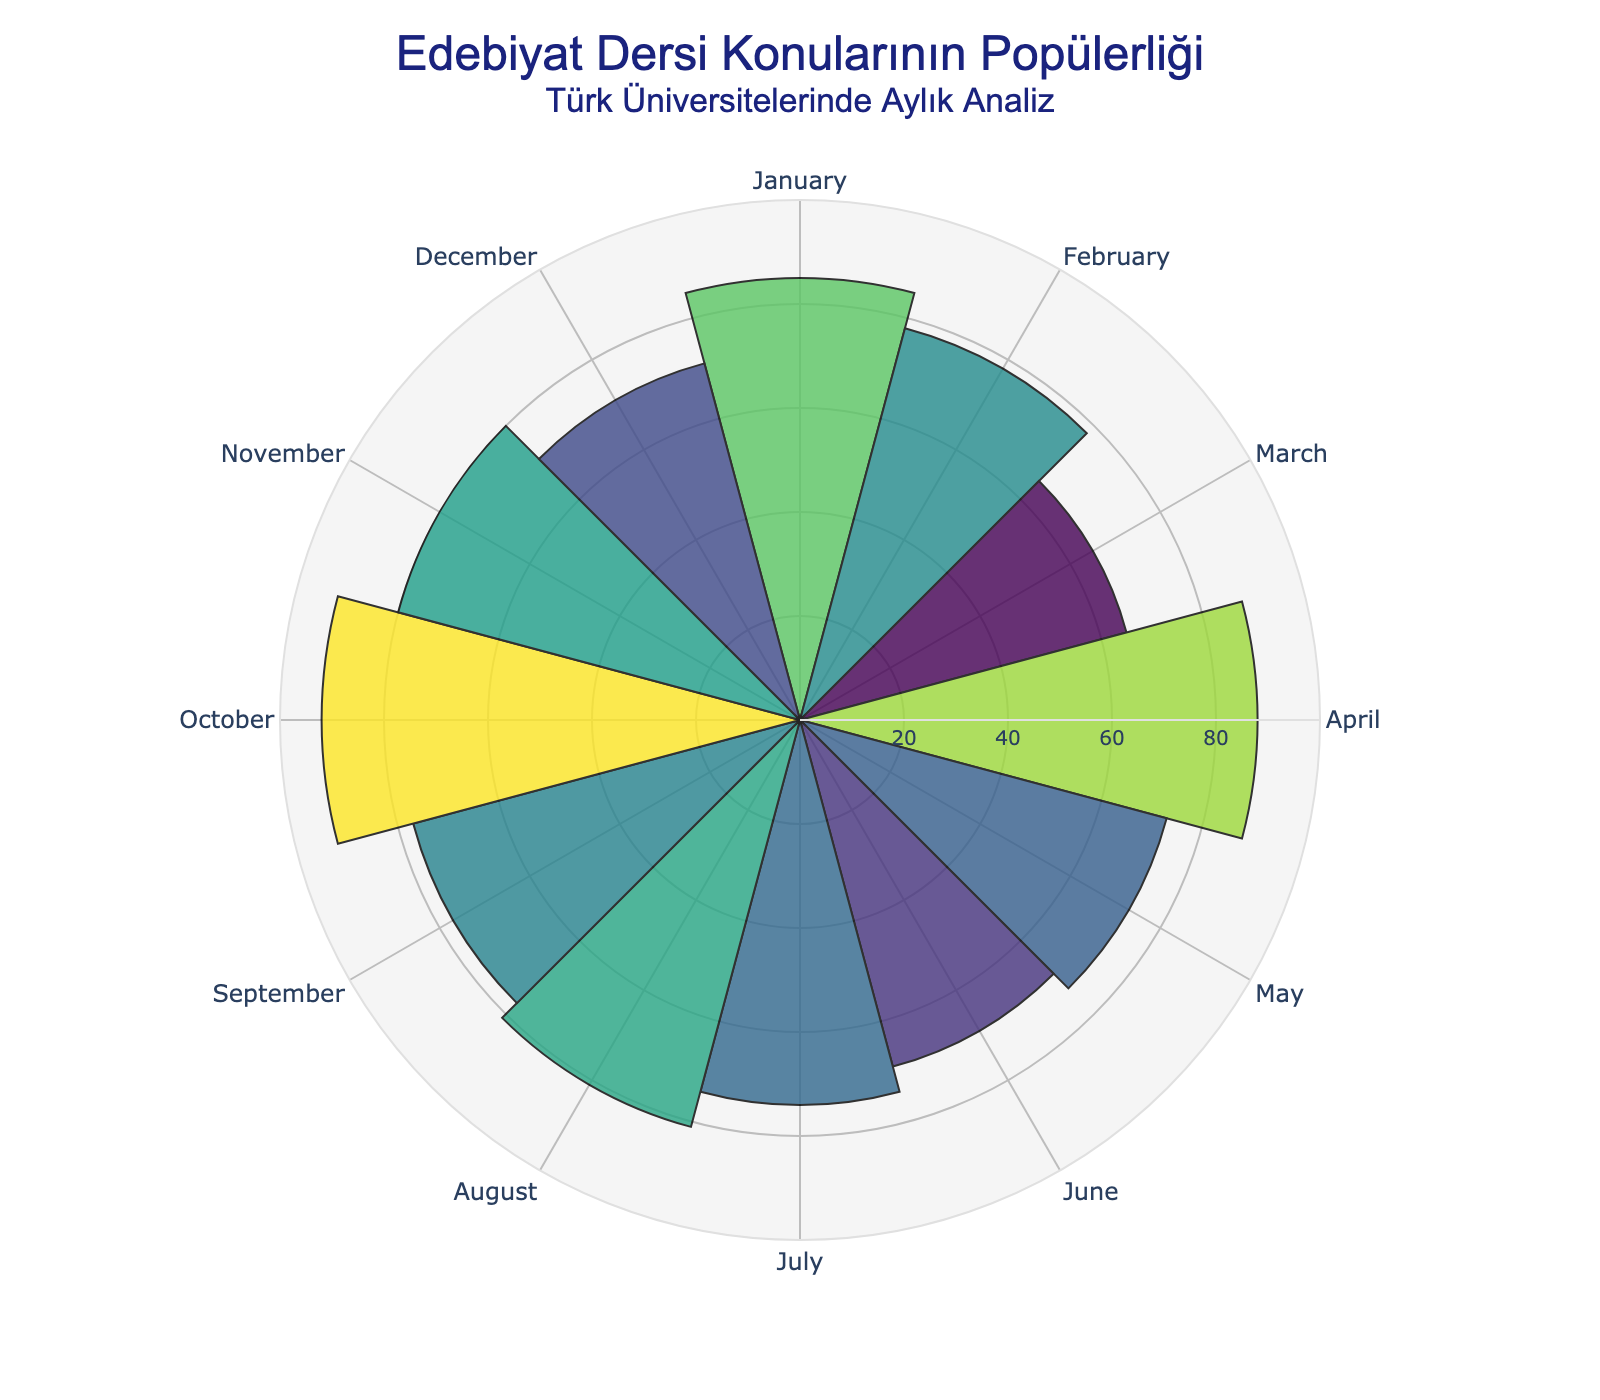What's the title of the figure? The title of the figure is generally located at the top and is usually in a larger font size for emphasis. Here, the title reads "Edebiyat Dersi Konularının Popülerliği" with a subtitle "Türk Üniversitelerinde Aylık Analiz."
Answer: Edebiyat Dersi Konularının Popülerliği Which lecture topic is most popular in October? To find this, locate October on the angular axis and refer to the corresponding bar. The hover text or height of the segment will indicate the most popular topic.
Answer: The Works of Elif Shafak Which month has the least popular lecture topic? By looking at the polar segments, we identify the smallest bar, which corresponds to March. The height of the polar bar or hover text gives us the topic and popularity.
Answer: March What's the average popularity of all lecture topics? Sum all the popularity values and divide by the number of lecture topics. The values are 85, 78, 65, 88, 73, 69, 74, 81, 77, 92, 80, 71. The average is (85+78+65+88+73+69+74+81+77+92+80+71)/12.
Answer: 77.25 Which two months have the closest lecture topic popularity values? Compare the popularity values visually or hover over each segment to find the two with the closest values. February (78) and September (77) have a difference of 1.
Answer: February and September What is the combined popularity of lecture topics in January and December? Add the popularity values for January (85) and December (71). The computation is 85 + 71.
Answer: 156 Are lecture topics more popular in the first half or the second half of the year? Sum the popularity values from January to June, and from July to December, then compare the two sums. First half: 85+78+65+88+73+69 = 458; Second half: 74+81+77+92+80+71 = 475.
Answer: Second half Which lecture topic discussed in August has a corresponding popularity value? Find August on the angular axis or the polar bar corresponding to it, and refer to the hover text which mentions the topic and its popularity.
Answer: Literary Translation: Challenges and Triumphs What is the range of lecture topic popularity values? Subtract the smallest popularity value from the largest. The smallest is 65 (March), and the largest is 92 (October). The range is 92 - 65.
Answer: 27 Which lecture topic had a noticeable peak in popularity compared to its neighboring months? Identify the spikes in the figure by comparing neighboring bars visually. April has a noticeable peak with 88 (Contemporary Turkish Female Poets), standing out compared to March (65) and May (73).
Answer: Contemporary Turkish Female Poets in April 